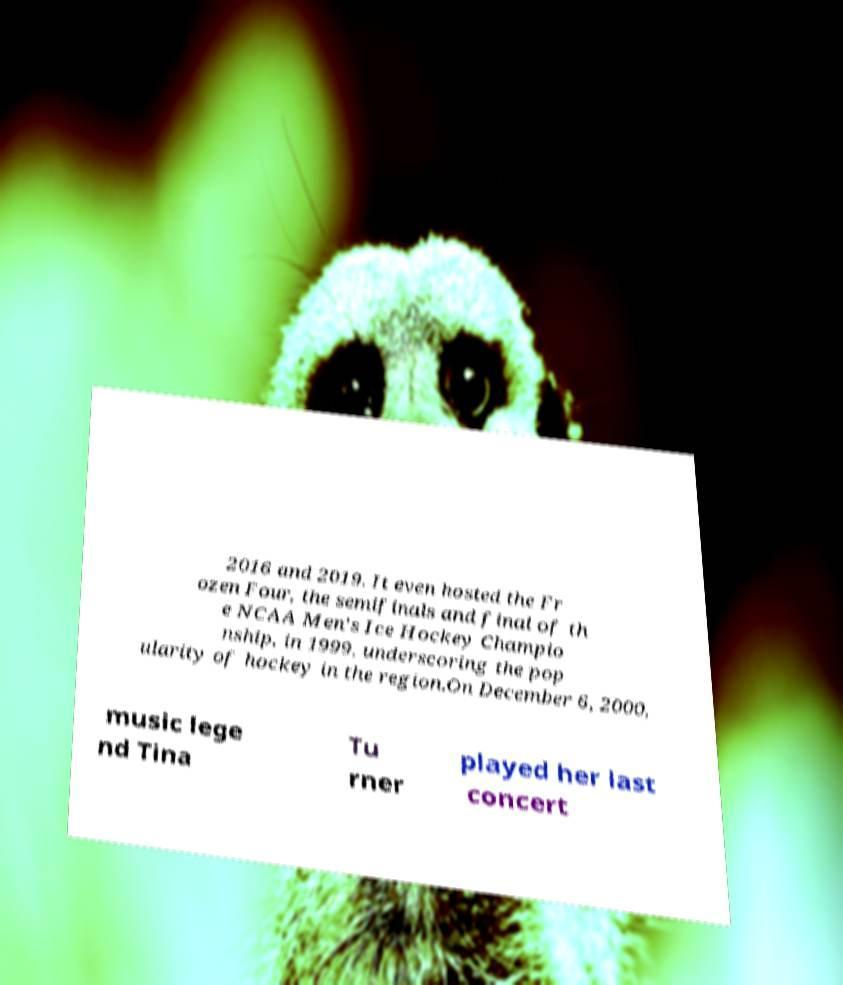Please identify and transcribe the text found in this image. 2016 and 2019. It even hosted the Fr ozen Four, the semifinals and final of th e NCAA Men's Ice Hockey Champio nship, in 1999, underscoring the pop ularity of hockey in the region.On December 6, 2000, music lege nd Tina Tu rner played her last concert 